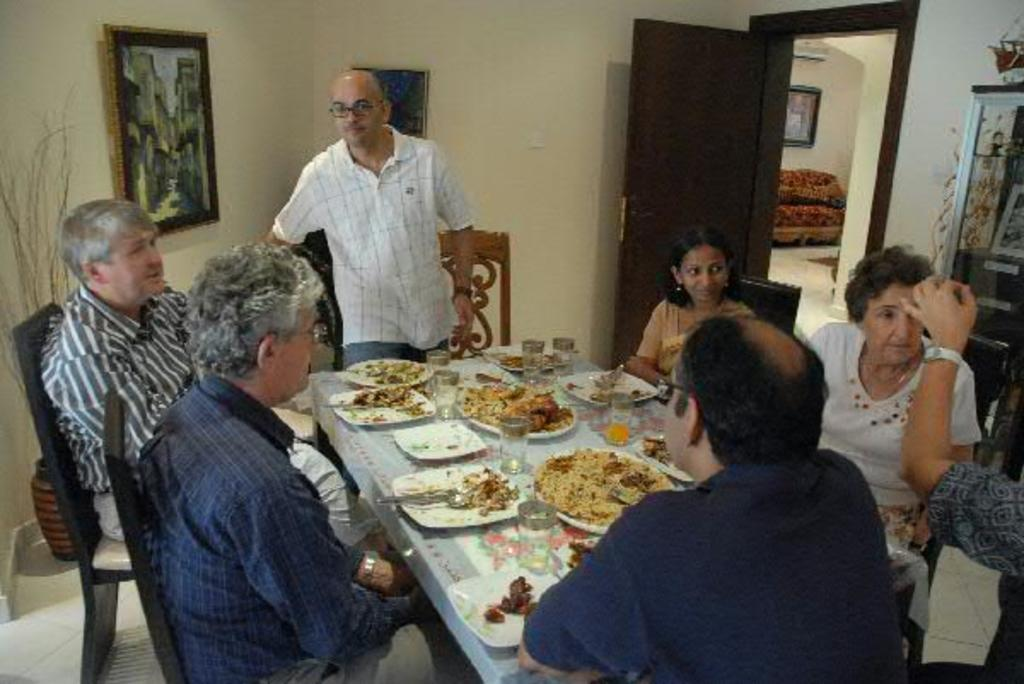What are the people in the image doing? There is a group of people sitting on chairs in the image. What can be seen on the table in the image? There is a plate, food, spoons, and glasses on the table in the image. What is present in the background of the image? There is a door and a frame attached to the wall in the background. What type of bone can be seen in the image? There is no bone present in the image. What health advice can be given based on the food in the image? We cannot give health advice based on the food in the image, as we do not have enough information about the specific food items or the context of the image. 